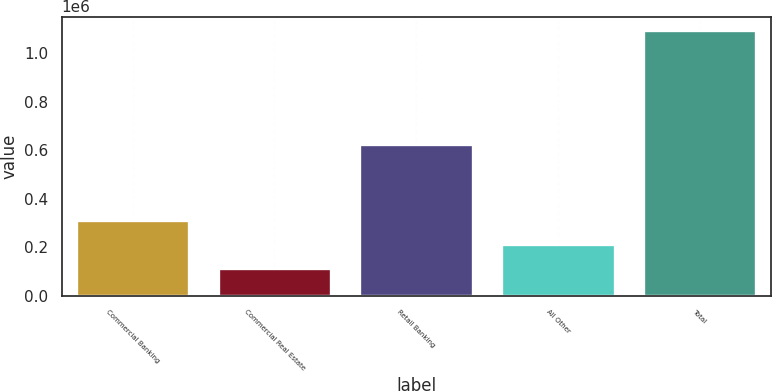<chart> <loc_0><loc_0><loc_500><loc_500><bar_chart><fcel>Commercial Banking<fcel>Commercial Real Estate<fcel>Retail Banking<fcel>All Other<fcel>Total<nl><fcel>311417<fcel>114883<fcel>627564<fcel>213150<fcel>1.09755e+06<nl></chart> 